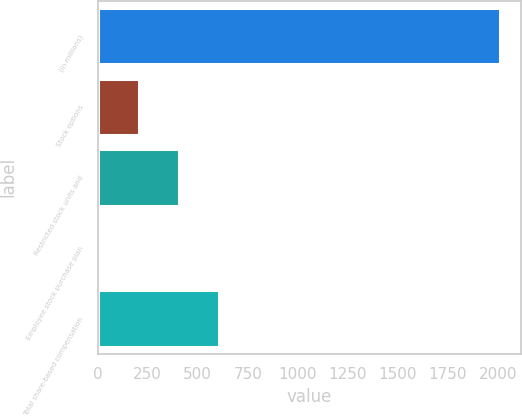Convert chart. <chart><loc_0><loc_0><loc_500><loc_500><bar_chart><fcel>(In millions)<fcel>Stock options<fcel>Restricted stock units and<fcel>Employee stock purchase plan<fcel>Total share-based compensation<nl><fcel>2014<fcel>204.55<fcel>405.6<fcel>3.5<fcel>606.65<nl></chart> 